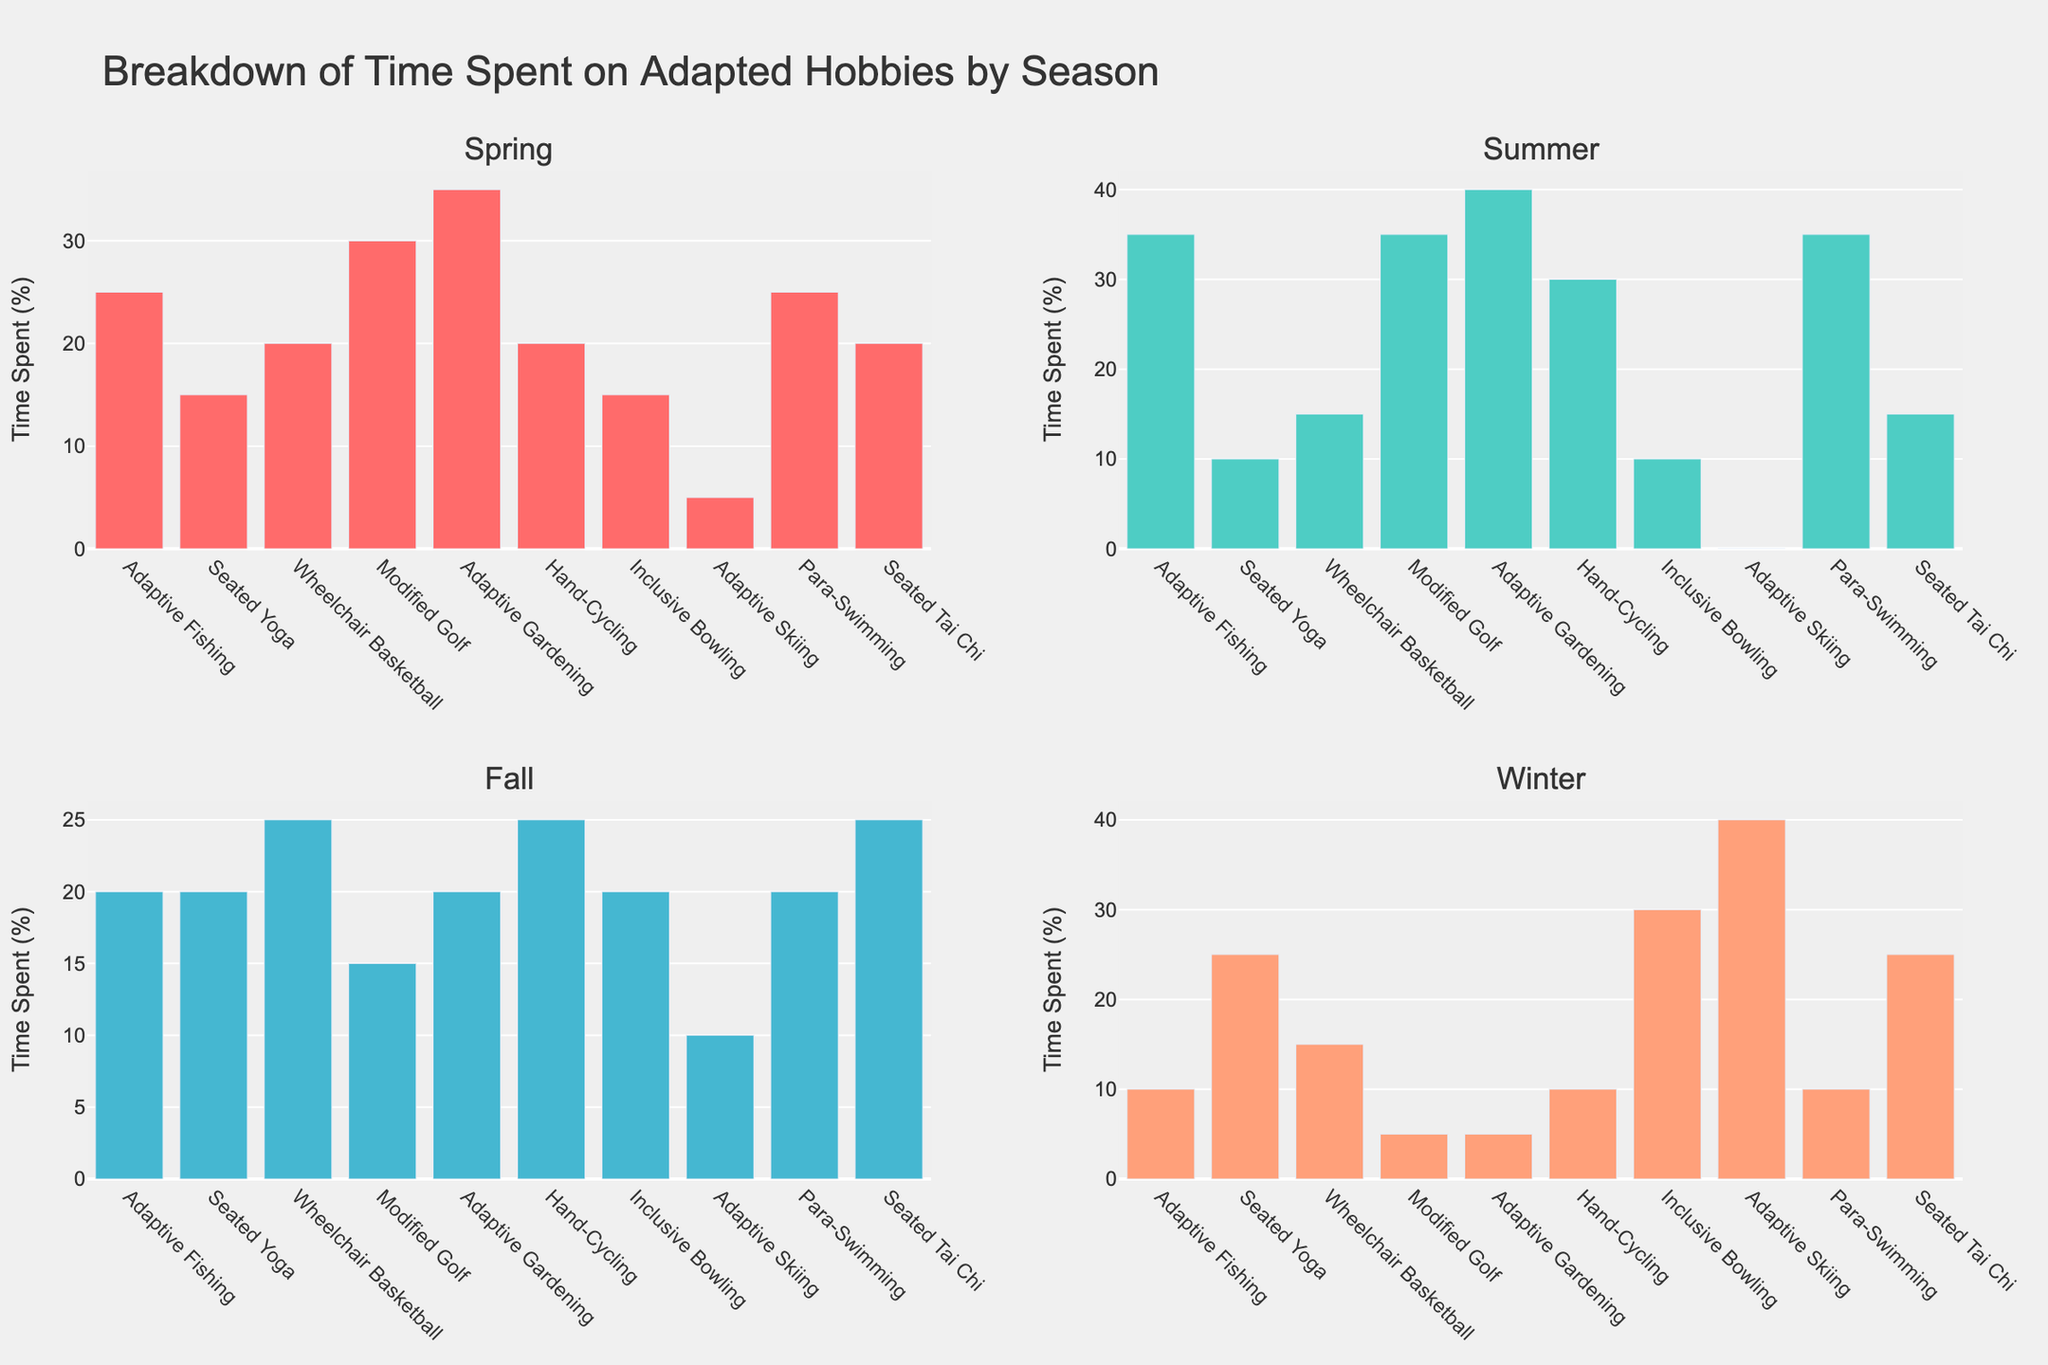What is the title of the figure? The title is displayed at the top of the figure and summarizes the content of the subplots.
Answer: "Breakdown of Time Spent on Adapted Hobbies by Season" Which hobby has the highest percentage of time spent in Summer? Look at the Summer subplot and identify which hobby has the highest bar.
Answer: Adaptive Gardening How does the time spent on Seated Yoga change across the seasons? Examine the height of the bars for Seated Yoga in each subplot (Spring, Summer, Fall, Winter).
Answer: 15% in Spring, 10% in Summer, 20% in Fall, 25% in Winter What is the total percentage of time spent on Modified Golf across all seasons? Add the percentages of time spent on Modified Golf in Spring, Summer, Fall, and Winter.
Answer: 30 + 35 + 15 + 5 = 85% Which season has the smallest percentage of time spent on Adaptive Skiing? Compare the percentage values of Adaptive Skiing for each season and find the smallest value.
Answer: Summer Which hobby shows the most significant increase in time spent from Fall to Winter? Compare the differences between Fall and Winter percentages for each hobby and identify the largest increase.
Answer: Adaptive Skiing (10% in Fall to 40% in Winter, increase of 30%) In which season is the total time spent on Para-Swimming and Hand-Cycling equal? Examine the percentages for Para-Swimming and Hand-Cycling in each season and find where their sum is equal.
Answer: Spring (25% + 20% = 45%) What is the average percentage of time spent on Seated Tai Chi across all seasons? Calculate the sum of percentages for Seated Tai Chi in all seasons and divide by four.
Answer: (20 + 15 + 25 + 25) / 4 = 21.25% Which hobby has the least variation in time spent across the seasons? Observe each hobby's percentages across the four subplots and identify the one with the smallest difference between maximum and minimum values.
Answer: Seated Tai Chi What are the two most popular hobbies in Spring based on the percentage of time spent? Look at the Spring subplot and identify the two hobbies with the highest bars.
Answer: Adaptive Gardening and Modified Golf 